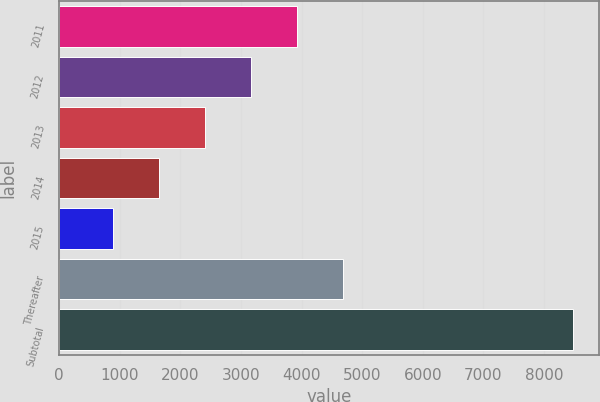<chart> <loc_0><loc_0><loc_500><loc_500><bar_chart><fcel>2011<fcel>2012<fcel>2013<fcel>2014<fcel>2015<fcel>Thereafter<fcel>Subtotal<nl><fcel>3924.2<fcel>3164.9<fcel>2405.6<fcel>1646.3<fcel>887<fcel>4683.5<fcel>8480<nl></chart> 